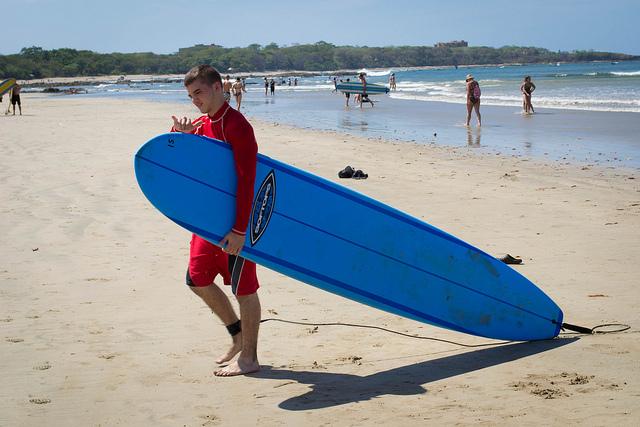What does the hand gesture mean that the guy is making?
Quick response, please. Hang loose. Is the surf dangerous?
Quick response, please. No. What is the man in the red and black suit doing?
Concise answer only. Holding surfboard. How many people are carrying surfboards?
Be succinct. 2. What color is her wetsuit?
Keep it brief. Red. 